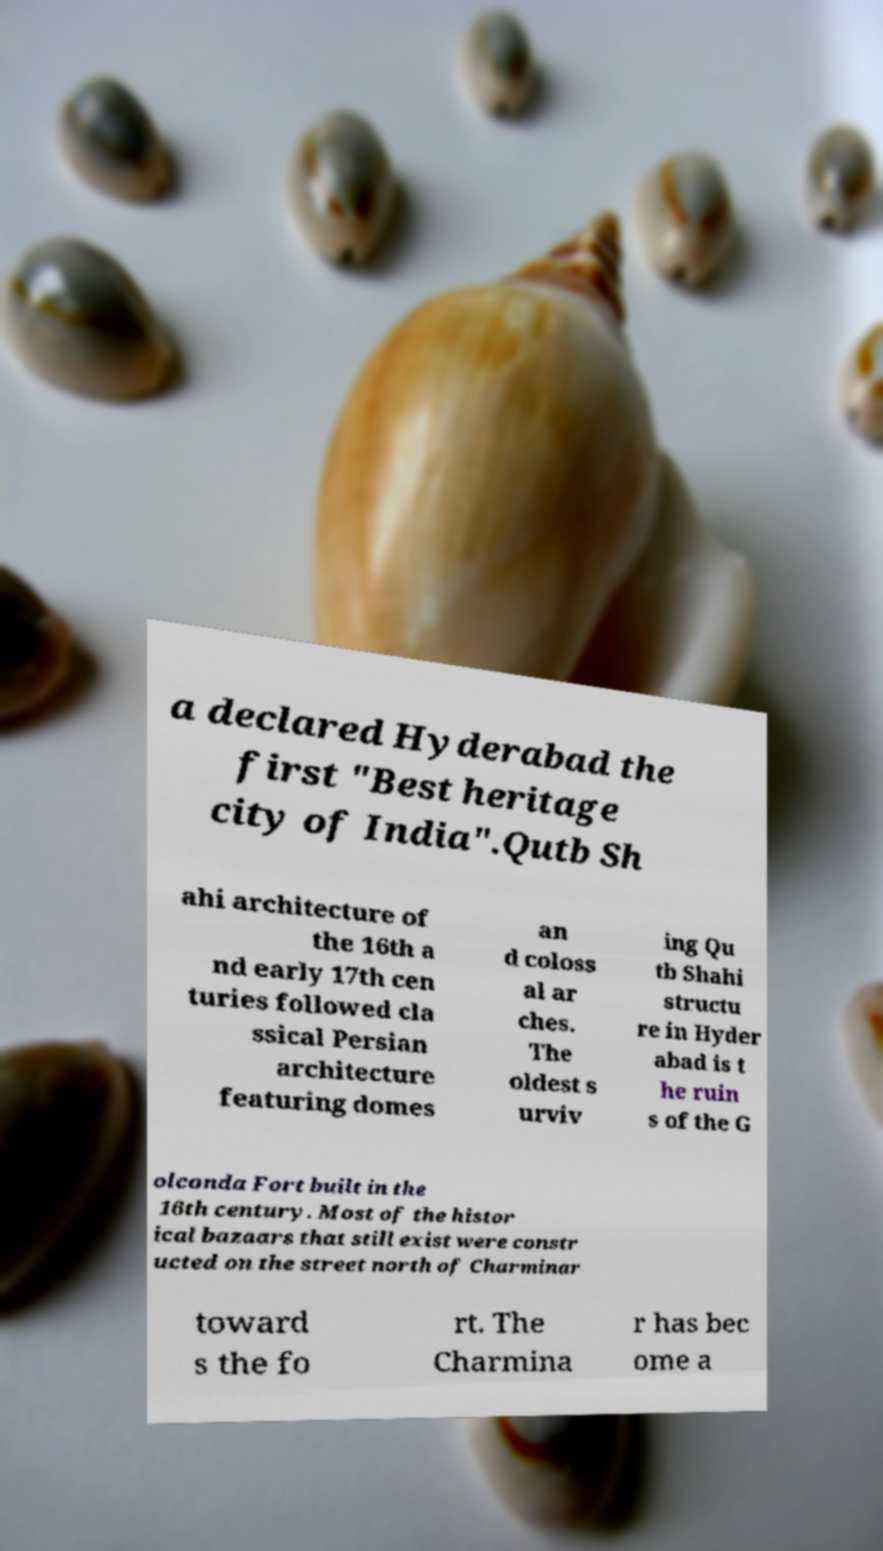What messages or text are displayed in this image? I need them in a readable, typed format. a declared Hyderabad the first "Best heritage city of India".Qutb Sh ahi architecture of the 16th a nd early 17th cen turies followed cla ssical Persian architecture featuring domes an d coloss al ar ches. The oldest s urviv ing Qu tb Shahi structu re in Hyder abad is t he ruin s of the G olconda Fort built in the 16th century. Most of the histor ical bazaars that still exist were constr ucted on the street north of Charminar toward s the fo rt. The Charmina r has bec ome a 